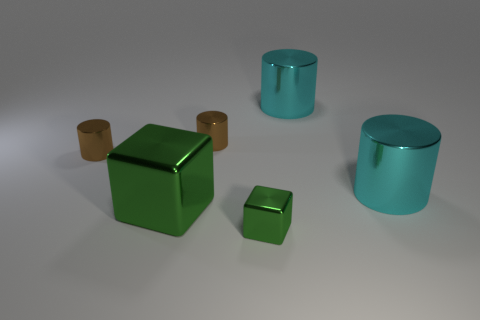Add 2 tiny brown objects. How many objects exist? 8 Subtract all blocks. How many objects are left? 4 Add 5 small brown things. How many small brown things exist? 7 Subtract 2 green cubes. How many objects are left? 4 Subtract all big metal cylinders. Subtract all big green objects. How many objects are left? 3 Add 5 tiny green shiny cubes. How many tiny green shiny cubes are left? 6 